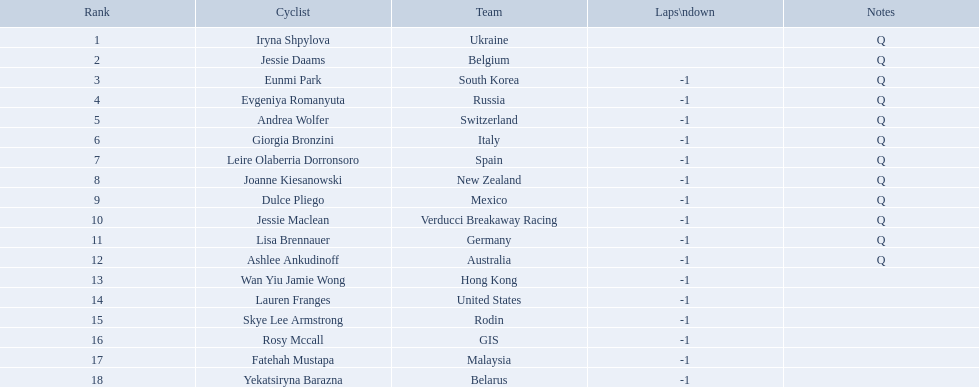Who competed in the race? Iryna Shpylova, Jessie Daams, Eunmi Park, Evgeniya Romanyuta, Andrea Wolfer, Giorgia Bronzini, Leire Olaberria Dorronsoro, Joanne Kiesanowski, Dulce Pliego, Jessie Maclean, Lisa Brennauer, Ashlee Ankudinoff, Wan Yiu Jamie Wong, Lauren Franges, Skye Lee Armstrong, Rosy Mccall, Fatehah Mustapa, Yekatsiryna Barazna. Who ranked highest in the race? Iryna Shpylova. Who are all the cycle racers? Iryna Shpylova, Jessie Daams, Eunmi Park, Evgeniya Romanyuta, Andrea Wolfer, Giorgia Bronzini, Leire Olaberria Dorronsoro, Joanne Kiesanowski, Dulce Pliego, Jessie Maclean, Lisa Brennauer, Ashlee Ankudinoff, Wan Yiu Jamie Wong, Lauren Franges, Skye Lee Armstrong, Rosy Mccall, Fatehah Mustapa, Yekatsiryna Barazna. What were their placements? 1, 2, 3, 4, 5, 6, 7, 8, 9, 10, 11, 12, 13, 14, 15, 16, 17, 18. Who held the highest rank? Iryna Shpylova. Who are all the participants on bikes in this race? Iryna Shpylova, Jessie Daams, Eunmi Park, Evgeniya Romanyuta, Andrea Wolfer, Giorgia Bronzini, Leire Olaberria Dorronsoro, Joanne Kiesanowski, Dulce Pliego, Jessie Maclean, Lisa Brennauer, Ashlee Ankudinoff, Wan Yiu Jamie Wong, Lauren Franges, Skye Lee Armstrong, Rosy Mccall, Fatehah Mustapa, Yekatsiryna Barazna. From them, which one possesses the smallest numbered rank? Iryna Shpylova. Who are all the bike riders? Iryna Shpylova, Jessie Daams, Eunmi Park, Evgeniya Romanyuta, Andrea Wolfer, Giorgia Bronzini, Leire Olaberria Dorronsoro, Joanne Kiesanowski, Dulce Pliego, Jessie Maclean, Lisa Brennauer, Ashlee Ankudinoff, Wan Yiu Jamie Wong, Lauren Franges, Skye Lee Armstrong, Rosy Mccall, Fatehah Mustapa, Yekatsiryna Barazna. What were their positions? 1, 2, 3, 4, 5, 6, 7, 8, 9, 10, 11, 12, 13, 14, 15, 16, 17, 18. Who had the top rank? Iryna Shpylova. Who are the cyclists involved? Iryna Shpylova, Jessie Daams, Eunmi Park, Evgeniya Romanyuta, Andrea Wolfer, Giorgia Bronzini, Leire Olaberria Dorronsoro, Joanne Kiesanowski, Dulce Pliego, Jessie Maclean, Lisa Brennauer, Ashlee Ankudinoff, Wan Yiu Jamie Wong, Lauren Franges, Skye Lee Armstrong, Rosy Mccall, Fatehah Mustapa, Yekatsiryna Barazna. What were their respective rankings? 1, 2, 3, 4, 5, 6, 7, 8, 9, 10, 11, 12, 13, 14, 15, 16, 17, 18. Who achieved the highest rank? Iryna Shpylova. Can you list all the cyclists? Iryna Shpylova, Jessie Daams, Eunmi Park, Evgeniya Romanyuta, Andrea Wolfer, Giorgia Bronzini, Leire Olaberria Dorronsoro, Joanne Kiesanowski, Dulce Pliego, Jessie Maclean, Lisa Brennauer, Ashlee Ankudinoff, Wan Yiu Jamie Wong, Lauren Franges, Skye Lee Armstrong, Rosy Mccall, Fatehah Mustapa, Yekatsiryna Barazna. What was the ranking of each one? 1, 2, 3, 4, 5, 6, 7, 8, 9, 10, 11, 12, 13, 14, 15, 16, 17, 18. Who had the highest ranking? Iryna Shpylova. Who were the competitors in the race? Iryna Shpylova, Jessie Daams, Eunmi Park, Evgeniya Romanyuta, Andrea Wolfer, Giorgia Bronzini, Leire Olaberria Dorronsoro, Joanne Kiesanowski, Dulce Pliego, Jessie Maclean, Lisa Brennauer, Ashlee Ankudinoff, Wan Yiu Jamie Wong, Lauren Franges, Skye Lee Armstrong, Rosy Mccall, Fatehah Mustapa, Yekatsiryna Barazna. Who claimed the highest spot in the race? Iryna Shpylova. 